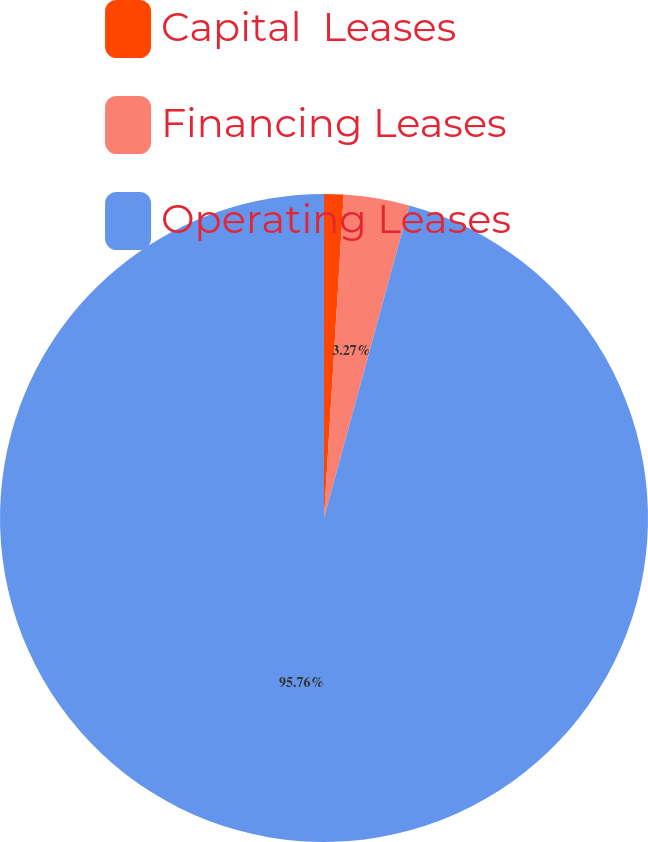Convert chart to OTSL. <chart><loc_0><loc_0><loc_500><loc_500><pie_chart><fcel>Capital  Leases<fcel>Financing Leases<fcel>Operating Leases<nl><fcel>0.97%<fcel>3.27%<fcel>95.76%<nl></chart> 